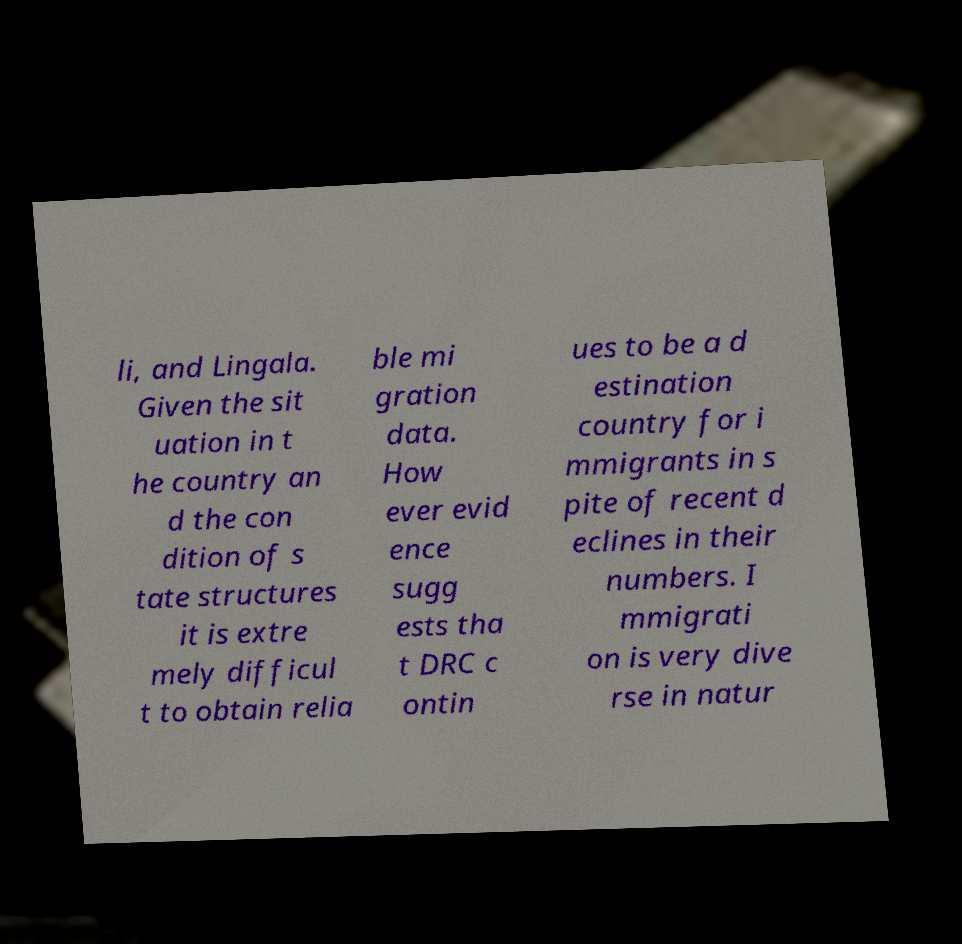Can you read and provide the text displayed in the image?This photo seems to have some interesting text. Can you extract and type it out for me? li, and Lingala. Given the sit uation in t he country an d the con dition of s tate structures it is extre mely difficul t to obtain relia ble mi gration data. How ever evid ence sugg ests tha t DRC c ontin ues to be a d estination country for i mmigrants in s pite of recent d eclines in their numbers. I mmigrati on is very dive rse in natur 